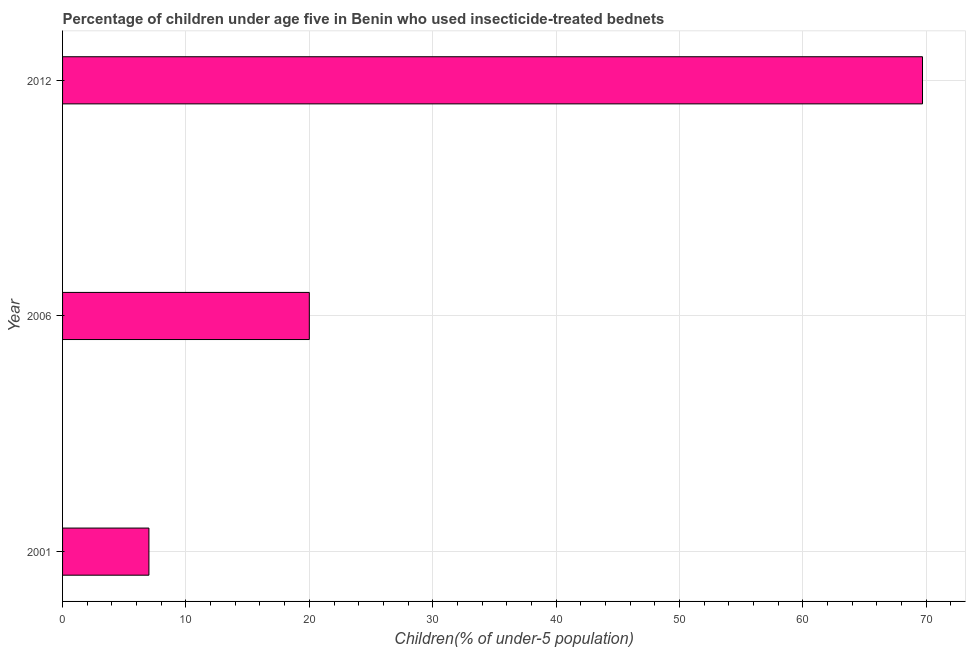What is the title of the graph?
Give a very brief answer. Percentage of children under age five in Benin who used insecticide-treated bednets. What is the label or title of the X-axis?
Provide a succinct answer. Children(% of under-5 population). What is the label or title of the Y-axis?
Keep it short and to the point. Year. Across all years, what is the maximum percentage of children who use of insecticide-treated bed nets?
Make the answer very short. 69.7. In which year was the percentage of children who use of insecticide-treated bed nets maximum?
Your response must be concise. 2012. In which year was the percentage of children who use of insecticide-treated bed nets minimum?
Provide a short and direct response. 2001. What is the sum of the percentage of children who use of insecticide-treated bed nets?
Your answer should be very brief. 96.7. What is the difference between the percentage of children who use of insecticide-treated bed nets in 2001 and 2012?
Your answer should be compact. -62.7. What is the average percentage of children who use of insecticide-treated bed nets per year?
Give a very brief answer. 32.23. Is the percentage of children who use of insecticide-treated bed nets in 2001 less than that in 2012?
Provide a short and direct response. Yes. Is the difference between the percentage of children who use of insecticide-treated bed nets in 2006 and 2012 greater than the difference between any two years?
Your answer should be compact. No. What is the difference between the highest and the second highest percentage of children who use of insecticide-treated bed nets?
Your answer should be compact. 49.7. What is the difference between the highest and the lowest percentage of children who use of insecticide-treated bed nets?
Your response must be concise. 62.7. How many bars are there?
Your answer should be very brief. 3. How many years are there in the graph?
Your response must be concise. 3. What is the difference between two consecutive major ticks on the X-axis?
Provide a succinct answer. 10. Are the values on the major ticks of X-axis written in scientific E-notation?
Ensure brevity in your answer.  No. What is the Children(% of under-5 population) in 2006?
Your answer should be compact. 20. What is the Children(% of under-5 population) in 2012?
Your answer should be very brief. 69.7. What is the difference between the Children(% of under-5 population) in 2001 and 2012?
Your answer should be very brief. -62.7. What is the difference between the Children(% of under-5 population) in 2006 and 2012?
Your answer should be compact. -49.7. What is the ratio of the Children(% of under-5 population) in 2006 to that in 2012?
Your response must be concise. 0.29. 